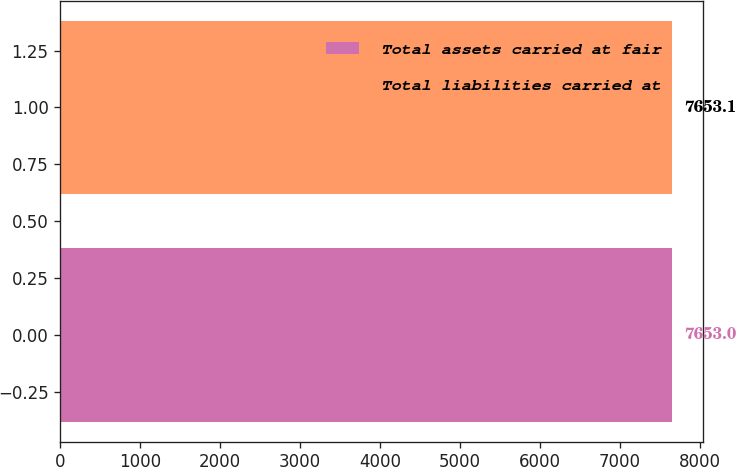Convert chart. <chart><loc_0><loc_0><loc_500><loc_500><bar_chart><fcel>Total assets carried at fair<fcel>Total liabilities carried at<nl><fcel>7653<fcel>7653.1<nl></chart> 